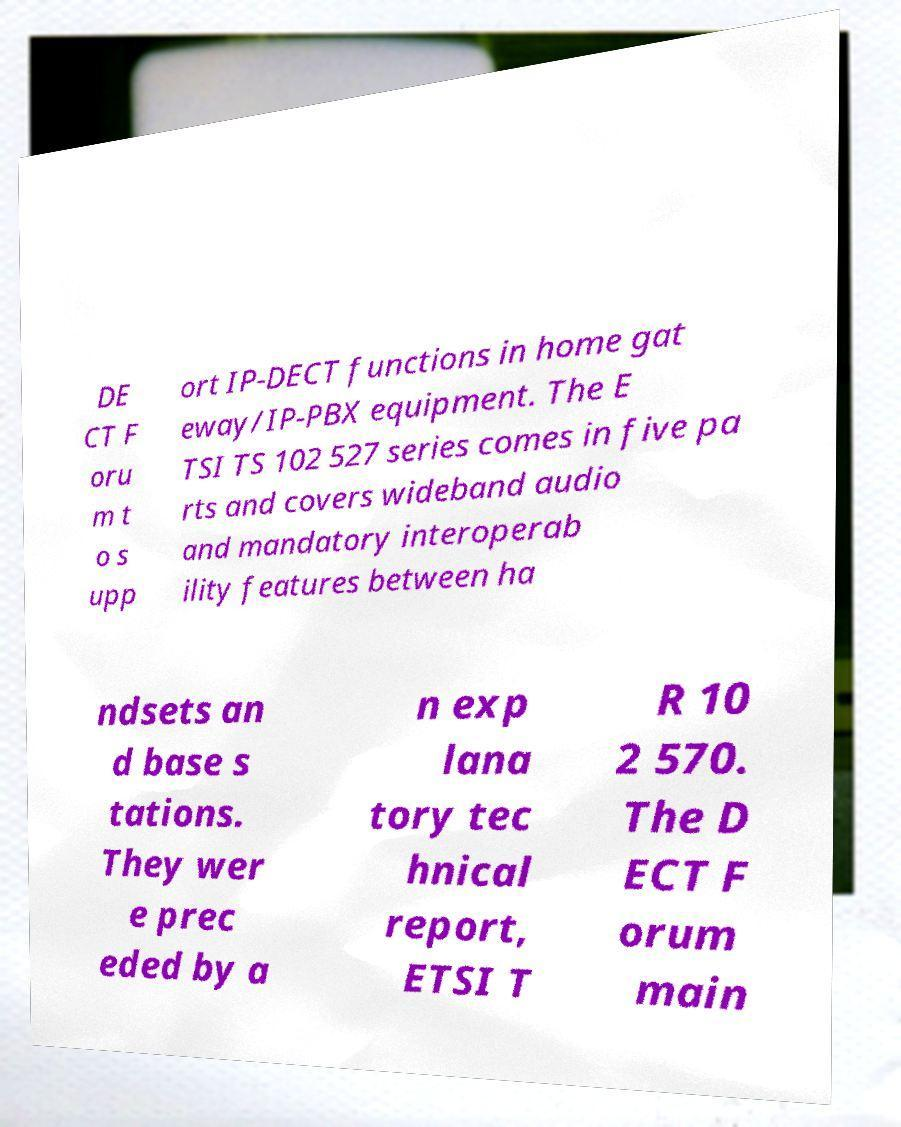For documentation purposes, I need the text within this image transcribed. Could you provide that? DE CT F oru m t o s upp ort IP-DECT functions in home gat eway/IP-PBX equipment. The E TSI TS 102 527 series comes in five pa rts and covers wideband audio and mandatory interoperab ility features between ha ndsets an d base s tations. They wer e prec eded by a n exp lana tory tec hnical report, ETSI T R 10 2 570. The D ECT F orum main 